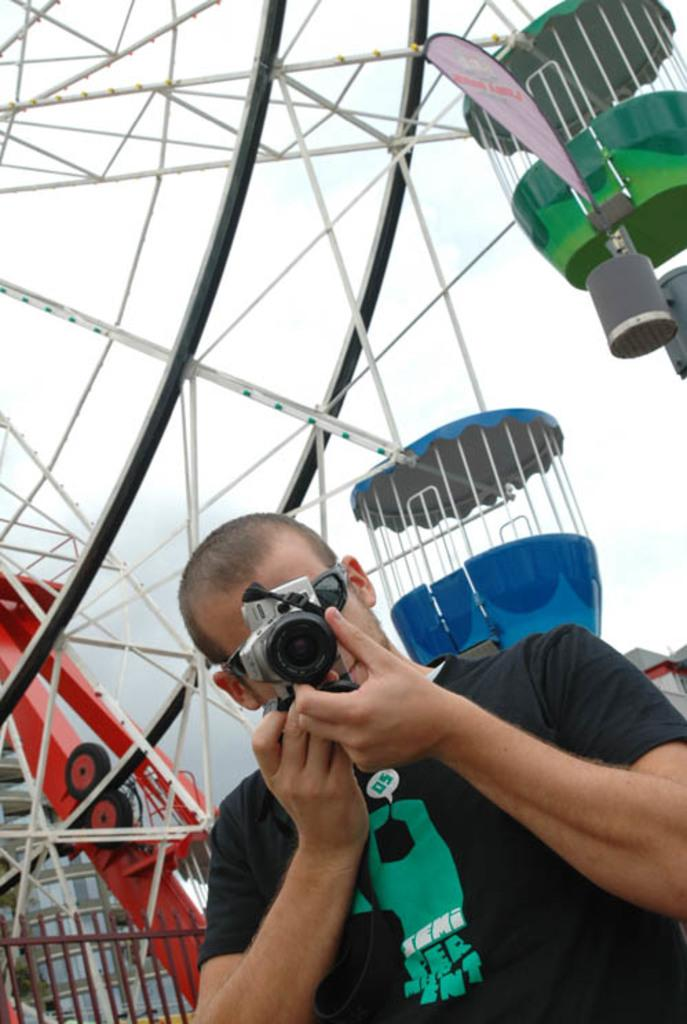What is the main object in the image? There is a giant wheel in the image. Can you describe the person in the image? A person is standing and holding a camera in the image. What is the purpose of the fence in the image? The fence is present in the image, but its purpose is not explicitly stated. What is the color of the sky in the image? The sky is white in color. How many centimeters does the person's mouth stretch when they smile in the image? There is no information about the person's mouth or their smile in the image, so this cannot be determined. --- 